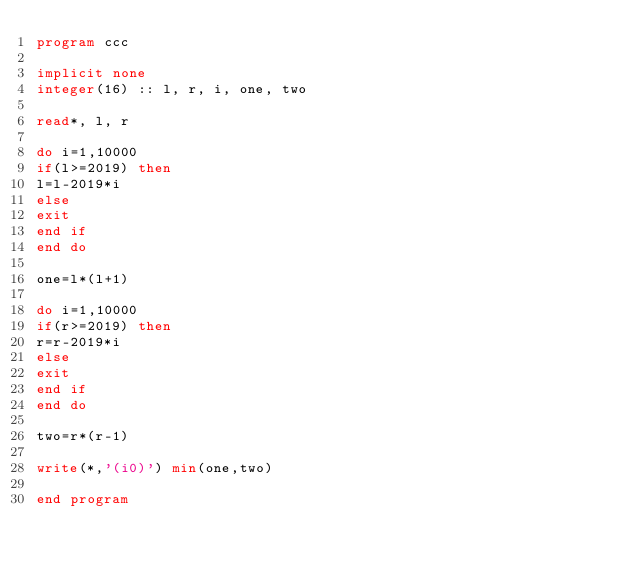<code> <loc_0><loc_0><loc_500><loc_500><_FORTRAN_>program ccc

implicit none
integer(16) :: l, r, i, one, two

read*, l, r

do i=1,10000
if(l>=2019) then
l=l-2019*i
else
exit
end if
end do

one=l*(l+1)

do i=1,10000
if(r>=2019) then
r=r-2019*i
else
exit
end if
end do

two=r*(r-1)

write(*,'(i0)') min(one,two)

end program</code> 